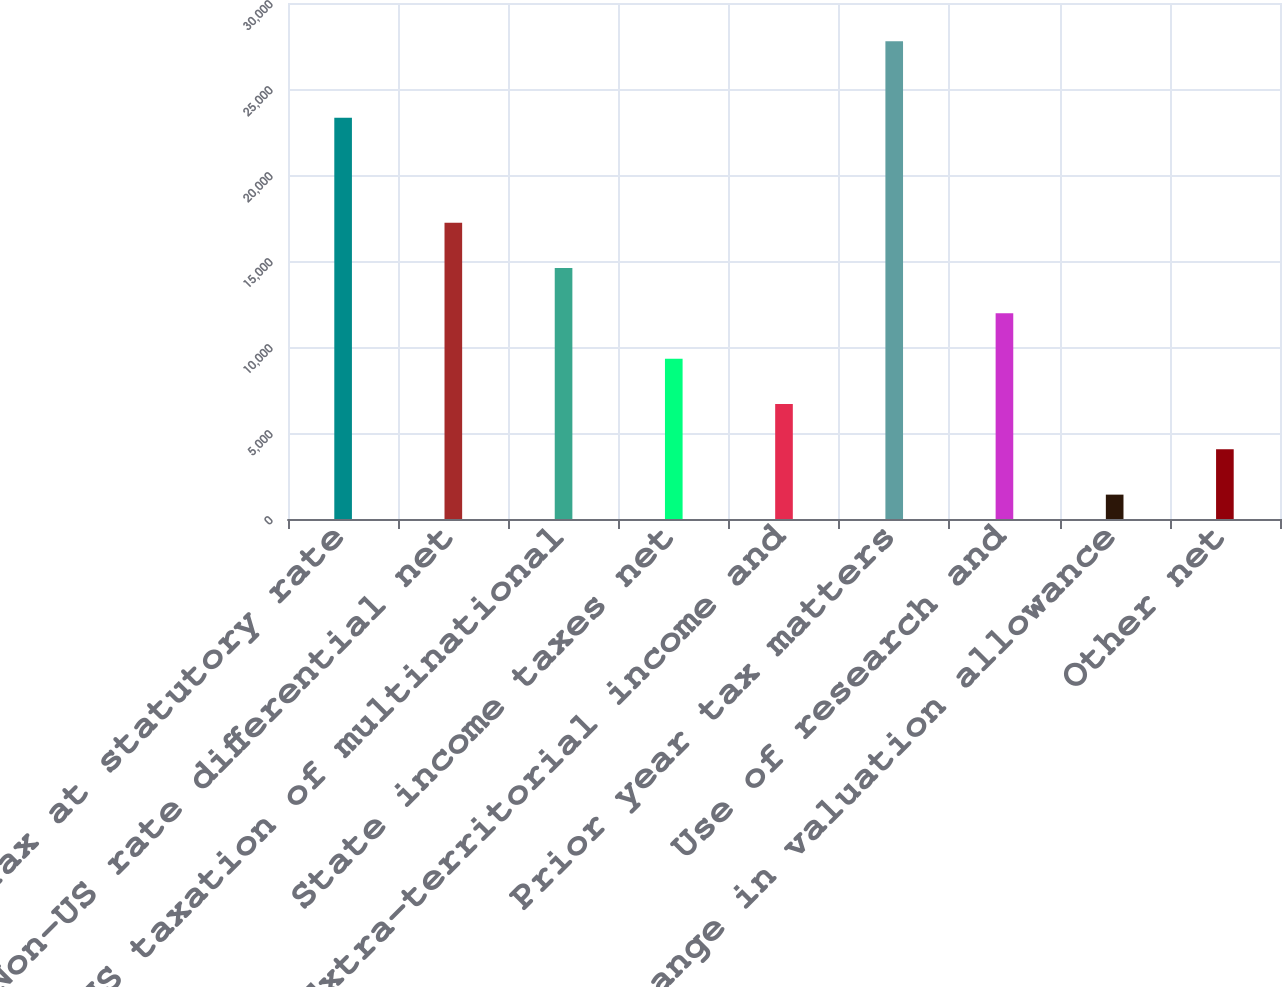Convert chart to OTSL. <chart><loc_0><loc_0><loc_500><loc_500><bar_chart><fcel>Tax at statutory rate<fcel>Non-US rate differential net<fcel>US taxation of multinational<fcel>State income taxes net<fcel>Extra-territorial income and<fcel>Prior year tax matters<fcel>Use of research and<fcel>Change in valuation allowance<fcel>Other net<nl><fcel>23331<fcel>17230<fcel>14594.5<fcel>9323.5<fcel>6688<fcel>27772<fcel>11959<fcel>1417<fcel>4052.5<nl></chart> 